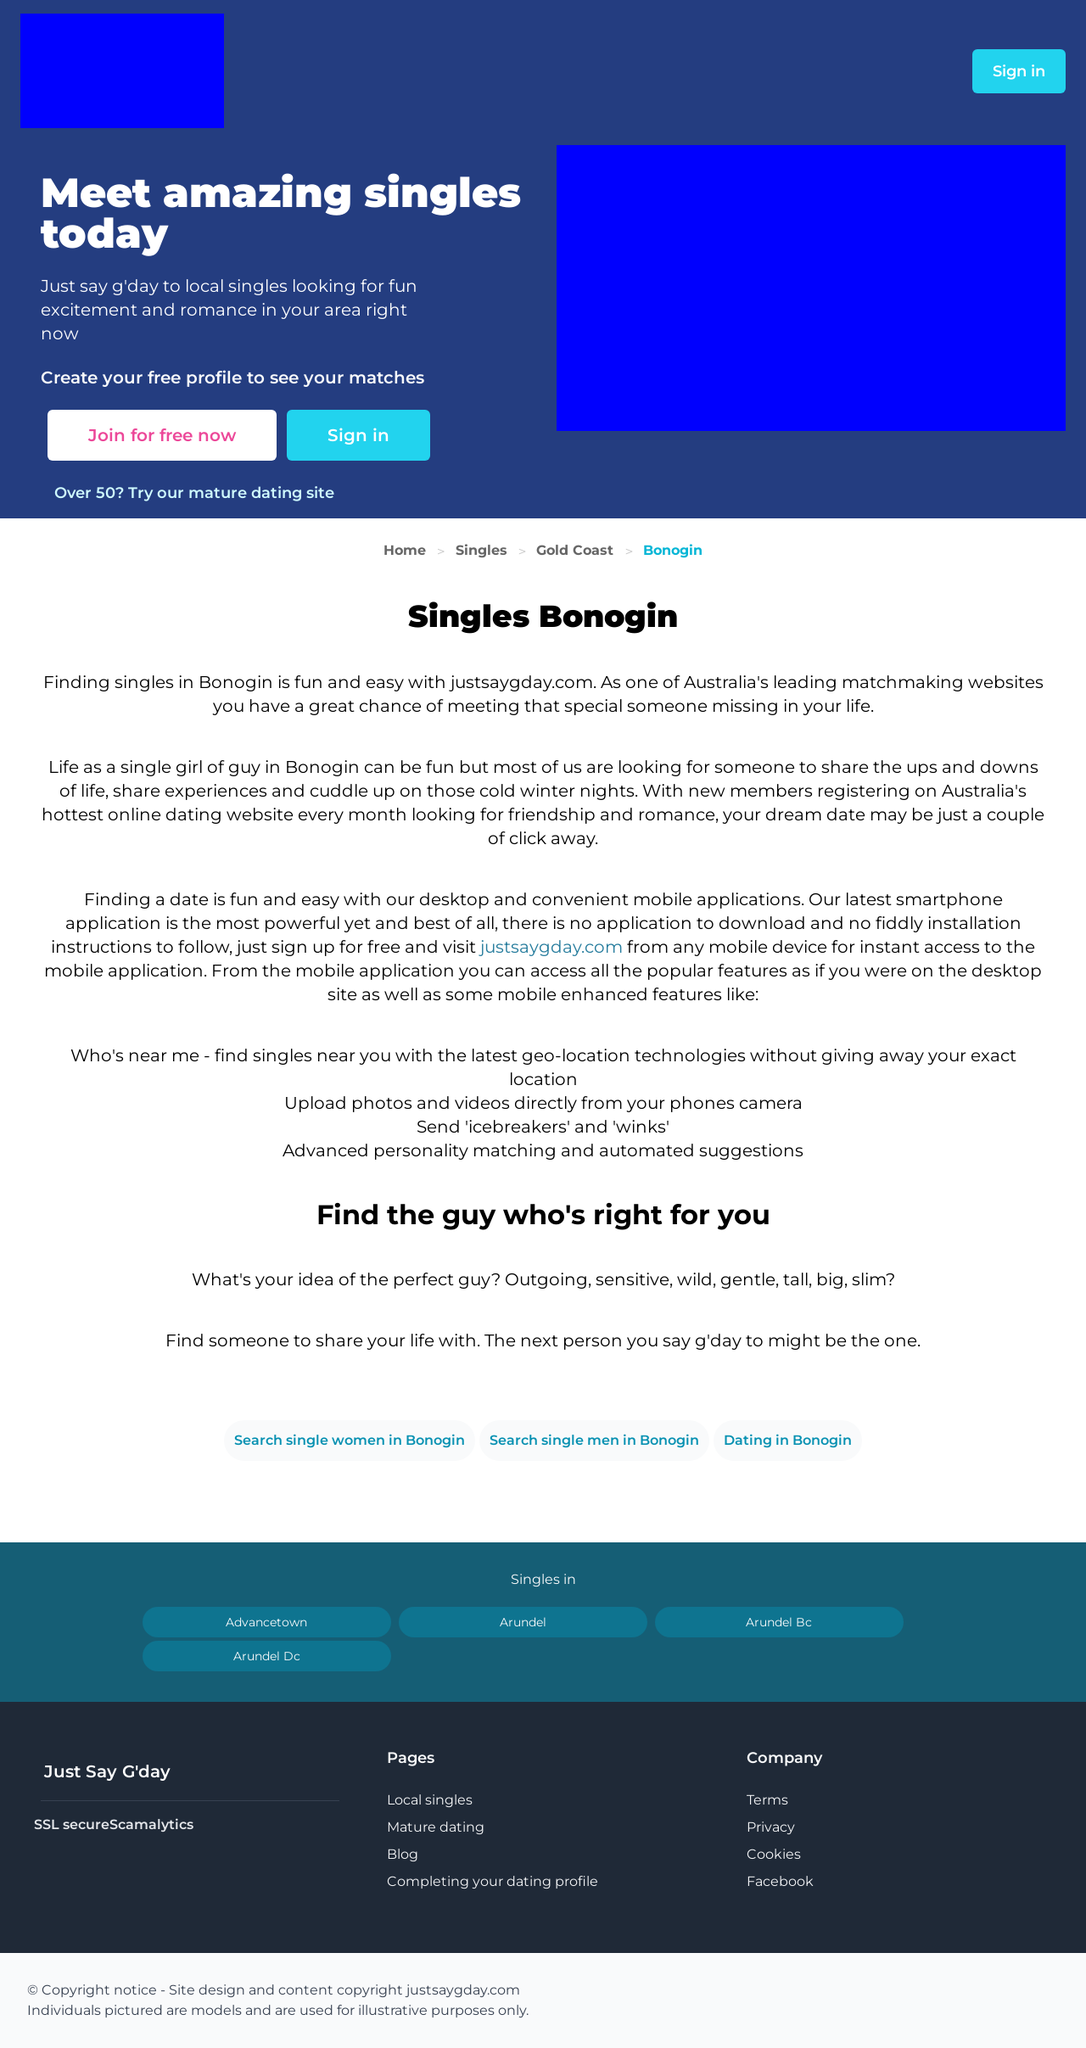What features are highlighted for the website displayed in the image? The website displayed in the image highlights several features: a robust matchmaking system, geo-location to find nearby singles without revealing exact locations, options for uploading photos and videos directly from mobile devices, and social features like sending ice breakers and winks. It also emphasizes usability across devices with a strong focus on mobile platforms.  How can the user privacy be ensured when using this dating website? User privacy on such a dating website can be ensured through several methods: using SSL certificates to encrypt data, not storing sensitive personal information unnecessarily, offering privacy settings that allow users to control what is visible to others, and making use of features like scamalytics which help detect and prevent fraudulent activities. 